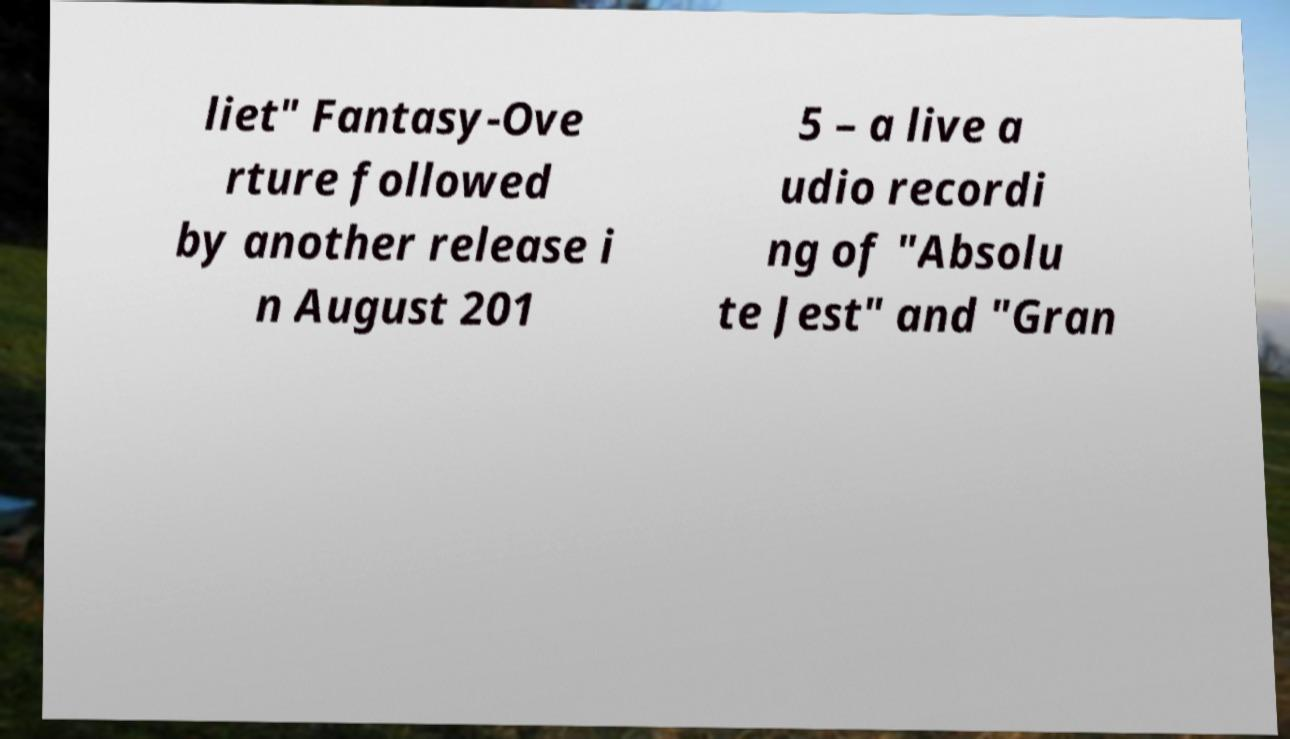Could you assist in decoding the text presented in this image and type it out clearly? liet" Fantasy-Ove rture followed by another release i n August 201 5 – a live a udio recordi ng of "Absolu te Jest" and "Gran 